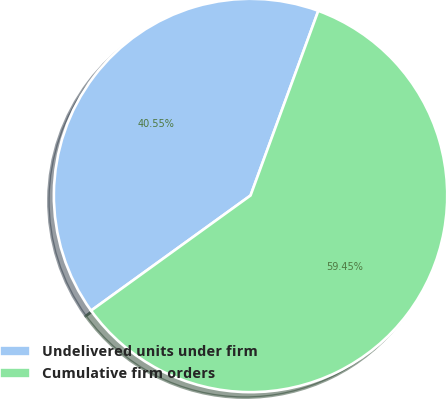Convert chart. <chart><loc_0><loc_0><loc_500><loc_500><pie_chart><fcel>Undelivered units under firm<fcel>Cumulative firm orders<nl><fcel>40.55%<fcel>59.45%<nl></chart> 